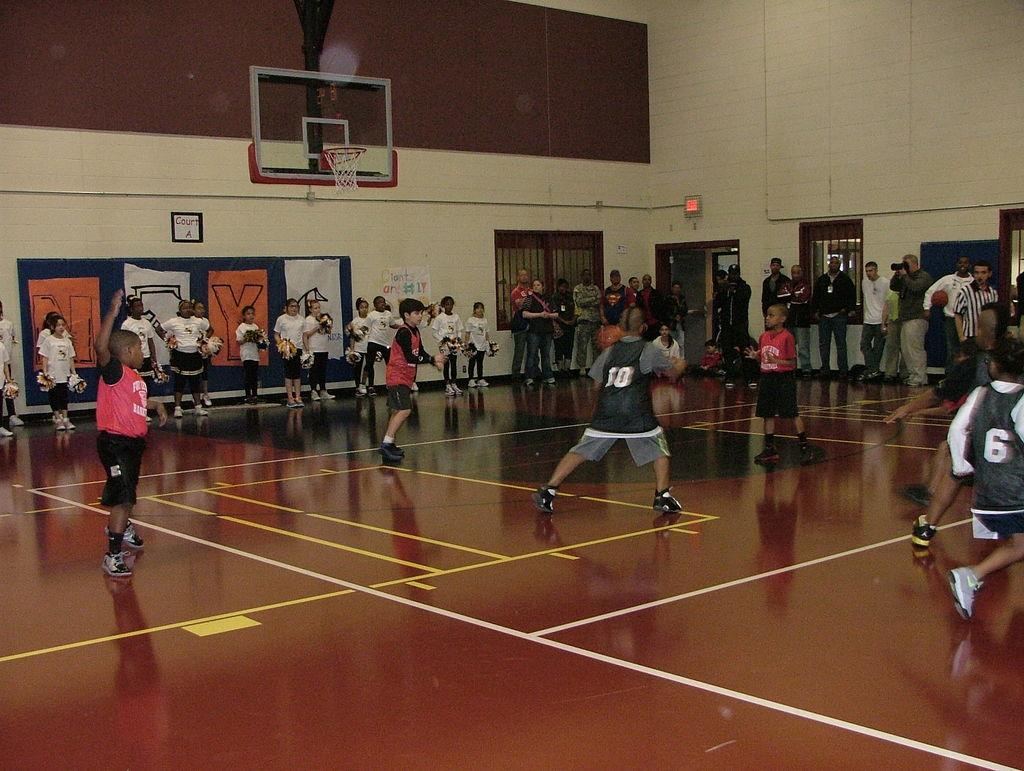Provide a one-sentence caption for the provided image. Inside a gymnasium, a group of boys play basketball with a sign on the wall saying "Giants are #1.". 